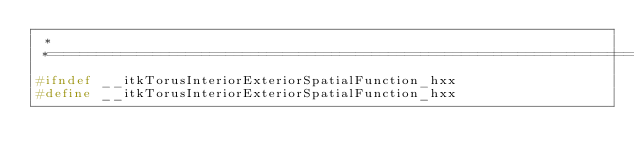Convert code to text. <code><loc_0><loc_0><loc_500><loc_500><_C++_> *
 *=========================================================================*/
#ifndef __itkTorusInteriorExteriorSpatialFunction_hxx
#define __itkTorusInteriorExteriorSpatialFunction_hxx
</code> 